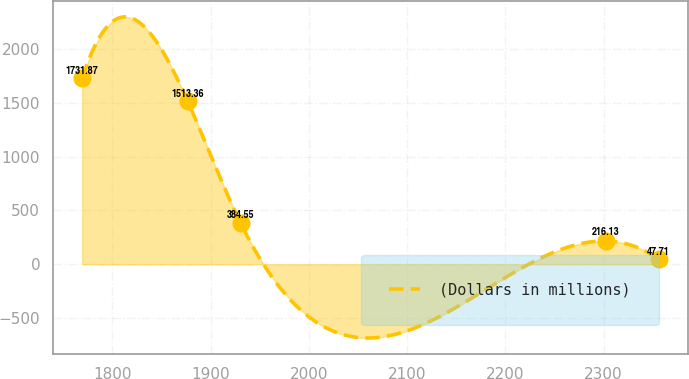Convert chart to OTSL. <chart><loc_0><loc_0><loc_500><loc_500><line_chart><ecel><fcel>(Dollars in millions)<nl><fcel>1769.19<fcel>1731.87<nl><fcel>1876.68<fcel>1513.36<nl><fcel>1930.32<fcel>384.55<nl><fcel>2302.4<fcel>216.13<nl><fcel>2356.04<fcel>47.71<nl></chart> 